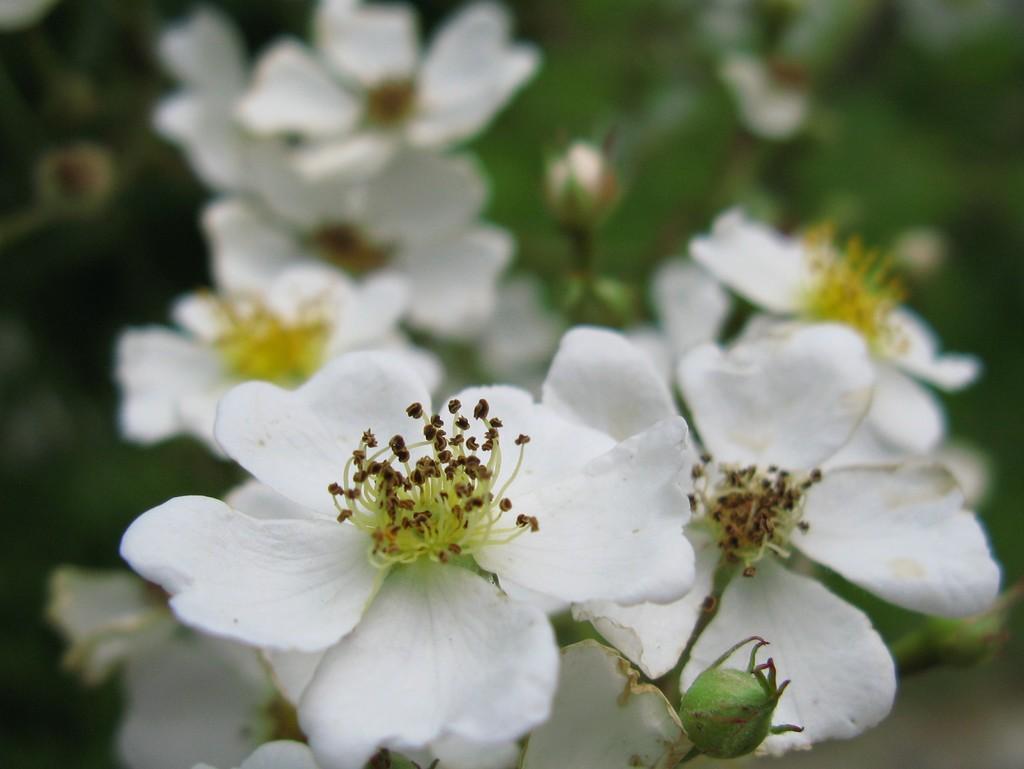Could you give a brief overview of what you see in this image? There are plants having white color flowers. And the background is blurred. 